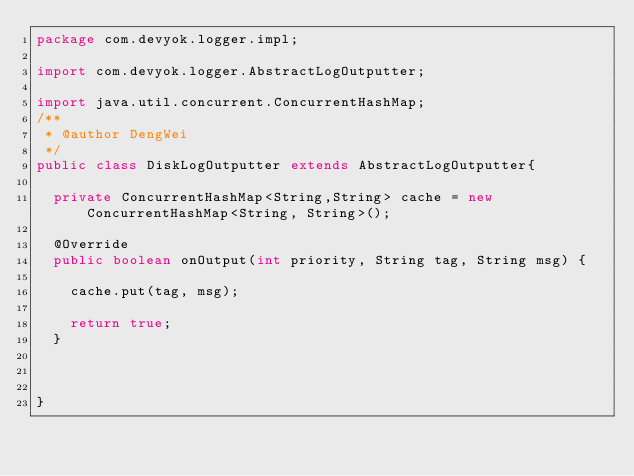<code> <loc_0><loc_0><loc_500><loc_500><_Java_>package com.devyok.logger.impl;

import com.devyok.logger.AbstractLogOutputter;

import java.util.concurrent.ConcurrentHashMap;
/**
 * @author DengWei
 */
public class DiskLogOutputter extends AbstractLogOutputter{

	private ConcurrentHashMap<String,String> cache = new ConcurrentHashMap<String, String>();
	
	@Override
	public boolean onOutput(int priority, String tag, String msg) {
		
		cache.put(tag, msg);
		
		return true;
	}

	

}
</code> 